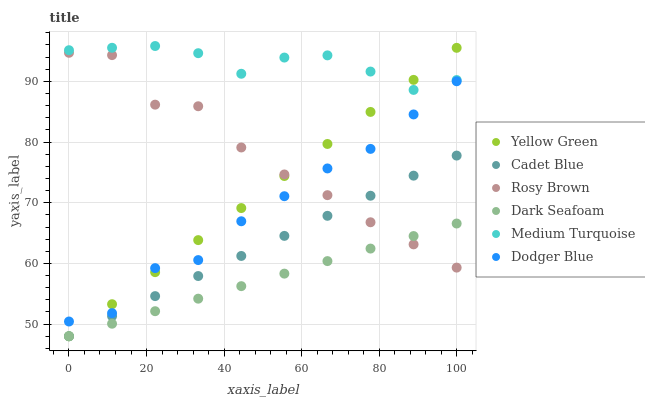Does Dark Seafoam have the minimum area under the curve?
Answer yes or no. Yes. Does Medium Turquoise have the maximum area under the curve?
Answer yes or no. Yes. Does Yellow Green have the minimum area under the curve?
Answer yes or no. No. Does Yellow Green have the maximum area under the curve?
Answer yes or no. No. Is Cadet Blue the smoothest?
Answer yes or no. Yes. Is Rosy Brown the roughest?
Answer yes or no. Yes. Is Yellow Green the smoothest?
Answer yes or no. No. Is Yellow Green the roughest?
Answer yes or no. No. Does Cadet Blue have the lowest value?
Answer yes or no. Yes. Does Rosy Brown have the lowest value?
Answer yes or no. No. Does Medium Turquoise have the highest value?
Answer yes or no. Yes. Does Yellow Green have the highest value?
Answer yes or no. No. Is Dodger Blue less than Medium Turquoise?
Answer yes or no. Yes. Is Medium Turquoise greater than Dodger Blue?
Answer yes or no. Yes. Does Dodger Blue intersect Yellow Green?
Answer yes or no. Yes. Is Dodger Blue less than Yellow Green?
Answer yes or no. No. Is Dodger Blue greater than Yellow Green?
Answer yes or no. No. Does Dodger Blue intersect Medium Turquoise?
Answer yes or no. No. 